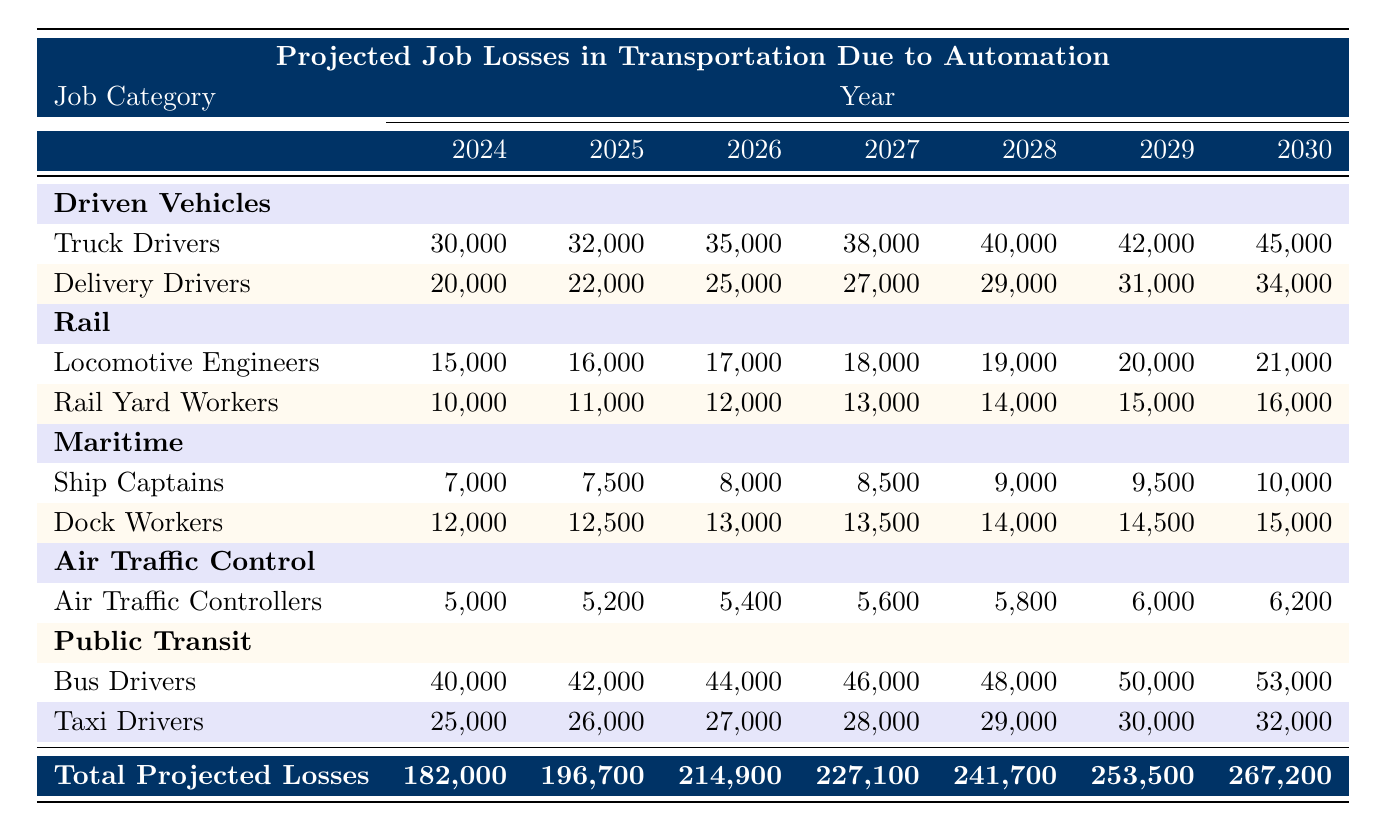What is the total projected job loss for 2027? The table shows the total projected job losses for each year. For 2027, the value is specifically listed as 227,100.
Answer: 227,100 Which job category has the highest projected losses in 2024? In 2024, the job category with the highest loss is "Bus Drivers" with 40,000 projected job losses, compared to other categories listed.
Answer: Bus Drivers What is the difference in projected job losses for Truck Drivers between 2024 and 2030? For Truck Drivers, the projected losses in 2024 are 30,000, and in 2030 they are 45,000. The difference is 45,000 - 30,000 = 15,000.
Answer: 15,000 What is the average number of job losses for Delivery Drivers from 2024 to 2030? To find the average, sum the projected losses for Delivery Drivers from 2024 to 2030: (20,000 + 22,000 + 25,000 + 27,000 + 29,000 + 31,000 + 34,000) = 188,000. There are 7 years, so average = 188,000 / 7 ≈ 26,857.
Answer: 26,857 Which job category shows a steady increase in losses over the decade? Upon reviewing the data, all job categories show an increase; however, "Locomotive Engineers" consistently increases the projected losses every year from 15,000 in 2024 to 21,000 in 2030.
Answer: Locomotive Engineers Are the total projected job losses for 2026 greater than for 2029? In the table, total projected job losses for 2026 are listed as 214,900 and for 2029 as 253,500. Therefore, 214,900 is not greater than 253,500, making the statement false.
Answer: No How much will the projected losses for Dock Workers increase from 2025 to 2028? The projected losses for Dock Workers in 2025 is 12,500 and in 2028 is 14,000. The increase is calculated as 14,000 - 12,500 = 1,500.
Answer: 1,500 What is the total number of job losses for Maritime workers in 2029? By adding the losses of Ship Captains (9,500) and Dock Workers (14,500) in 2029, we get the total: 9,500 + 14,500 = 24,000.
Answer: 24,000 Which year has the highest total projected job losses? By examining the total projected losses for each year, the highest value is found in 2030 with 267,200.
Answer: 2030 If you combine the losses from Air Traffic Controllers and Locomotive Engineers in 2026, what is the total? For Air Traffic Controllers, the projected losses in 2026 are 5,400, and for Locomotive Engineers, they are 17,000. The total is 5,400 + 17,000 = 22,400.
Answer: 22,400 Is it true that Taxi Drivers face greater job losses than Ship Captains in any year? A review of the data reveals that in every year from 2024 to 2030, job losses for Taxi Drivers exceed those of Ship Captains. Thus, this statement is true.
Answer: Yes 